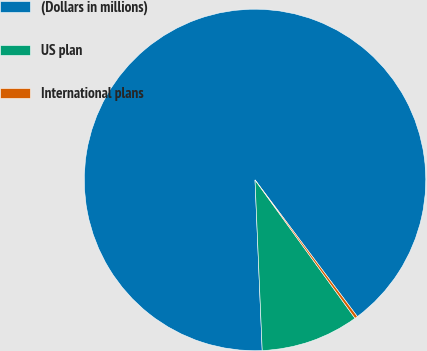Convert chart. <chart><loc_0><loc_0><loc_500><loc_500><pie_chart><fcel>(Dollars in millions)<fcel>US plan<fcel>International plans<nl><fcel>90.44%<fcel>9.29%<fcel>0.27%<nl></chart> 